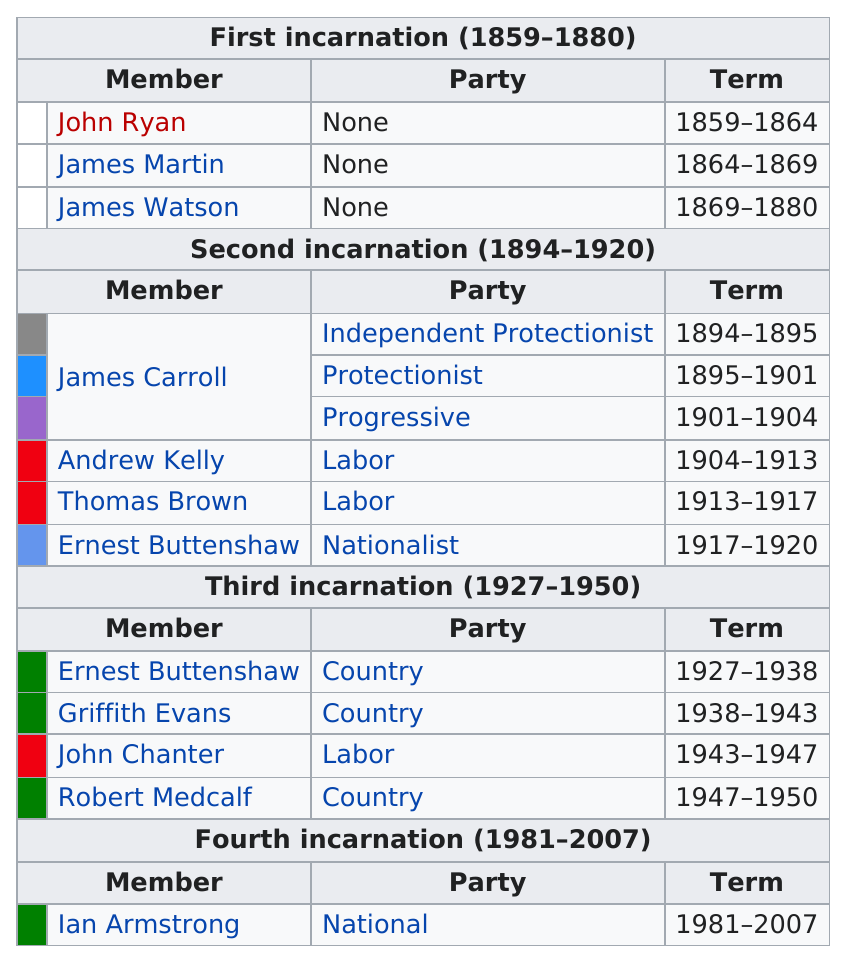List a handful of essential elements in this visual. Andrew Kelly served as a member after James Carroll. The members of the second incarnation have a combined total of 26 years of service. Ian Armstrong served for a total of 26 years. Ernest Bultitude was a member of the second incarnation of the Lachlan and he was also a nationalist. The fourth incarnation of Lachlan existed from 1981 to 2007. 